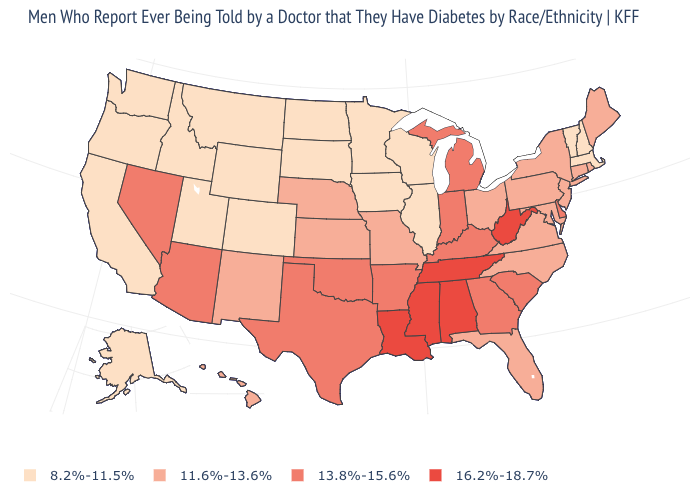What is the lowest value in states that border Indiana?
Keep it brief. 8.2%-11.5%. What is the value of Colorado?
Give a very brief answer. 8.2%-11.5%. Which states have the lowest value in the MidWest?
Write a very short answer. Illinois, Iowa, Minnesota, North Dakota, South Dakota, Wisconsin. Does Delaware have the same value as Michigan?
Short answer required. Yes. How many symbols are there in the legend?
Keep it brief. 4. Name the states that have a value in the range 8.2%-11.5%?
Give a very brief answer. Alaska, California, Colorado, Idaho, Illinois, Iowa, Massachusetts, Minnesota, Montana, New Hampshire, North Dakota, Oregon, South Dakota, Utah, Vermont, Washington, Wisconsin, Wyoming. How many symbols are there in the legend?
Short answer required. 4. Among the states that border Vermont , which have the lowest value?
Be succinct. Massachusetts, New Hampshire. What is the lowest value in states that border Montana?
Concise answer only. 8.2%-11.5%. Name the states that have a value in the range 16.2%-18.7%?
Be succinct. Alabama, Louisiana, Mississippi, Tennessee, West Virginia. Among the states that border Kentucky , does Tennessee have the highest value?
Short answer required. Yes. Does Indiana have the lowest value in the USA?
Concise answer only. No. Does Tennessee have the highest value in the South?
Be succinct. Yes. Does the first symbol in the legend represent the smallest category?
Quick response, please. Yes. How many symbols are there in the legend?
Give a very brief answer. 4. 